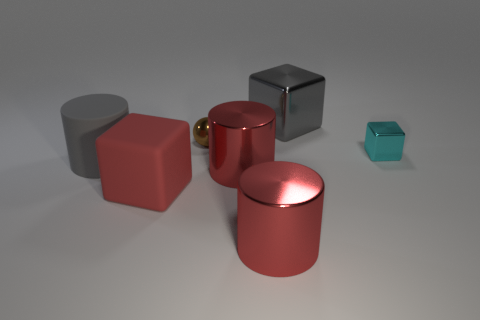Subtract all red metallic cylinders. How many cylinders are left? 1 Subtract all gray blocks. How many red cylinders are left? 2 Subtract 1 blocks. How many blocks are left? 2 Add 2 cyan matte blocks. How many objects exist? 9 Subtract all yellow cubes. Subtract all blue balls. How many cubes are left? 3 Subtract all spheres. How many objects are left? 6 Add 1 big cylinders. How many big cylinders are left? 4 Add 4 tiny metal blocks. How many tiny metal blocks exist? 5 Subtract 1 cyan cubes. How many objects are left? 6 Subtract all big gray things. Subtract all tiny brown metal spheres. How many objects are left? 4 